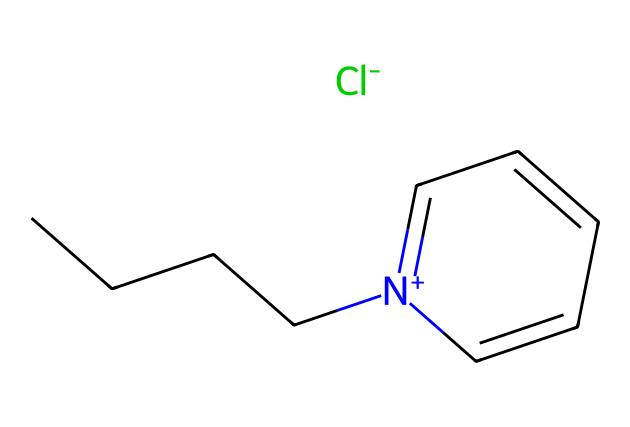What is the main function of the [Cl-] anion in this ionic liquid? The [Cl-] anion is responsible for charge neutrality in the ionic liquid structure, counterbalancing the positive charge of the pyridinium cation.
Answer: charge neutrality How many carbon atoms are present in the pyridinium cation? The pyridinium part of the ionic liquid includes six carbons in the ring and four in the butyl chain, totaling ten carbons.
Answer: ten What type of bonding characterizes the connection between the [Cl-] anion and the pyridinium cation? The bonding between the [Cl-] anion and the pyridinium cation is an ionic bond, as indicated by the electrostatic attraction between oppositely charged species.
Answer: ionic bond What makes pyridinium ionic liquids suitable for dissolving cellulose? The pyridinium ionic liquids have a high ability to disrupt hydrogen bonding in cellulose due to their ionic nature and polarity, facilitating cellulose dissolution.
Answer: high polarity What describes the arrangement of atoms in this ionic liquid's structure? The molecular arrangement includes a positively charged nitrogen center within a ring structure accompanied by a butyl side chain, indicating a cationic nature of this ionic liquid.
Answer: cationic nature How does the presence of the butyl group impact properties of the ionic liquid? The butyl group contributes to the solubility and viscosity characteristics of the ionic liquid, influencing its effectiveness in dissolving cellulose.
Answer: solubility and viscosity 